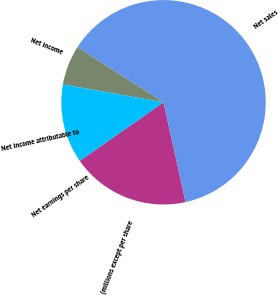Convert chart. <chart><loc_0><loc_0><loc_500><loc_500><pie_chart><fcel>(millions except per share<fcel>Net sales<fcel>Net income<fcel>Net income attributable to<fcel>Net earnings per share<nl><fcel>18.75%<fcel>62.48%<fcel>6.26%<fcel>12.5%<fcel>0.01%<nl></chart> 